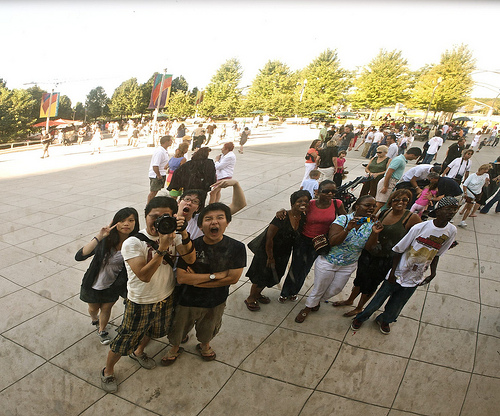<image>
Can you confirm if the camera is on the tree? No. The camera is not positioned on the tree. They may be near each other, but the camera is not supported by or resting on top of the tree. Where is the boy in relation to the girl? Is it next to the girl? No. The boy is not positioned next to the girl. They are located in different areas of the scene. 